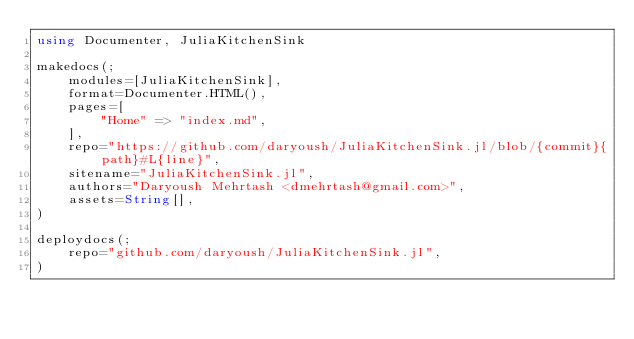<code> <loc_0><loc_0><loc_500><loc_500><_Julia_>using Documenter, JuliaKitchenSink

makedocs(;
    modules=[JuliaKitchenSink],
    format=Documenter.HTML(),
    pages=[
        "Home" => "index.md",
    ],
    repo="https://github.com/daryoush/JuliaKitchenSink.jl/blob/{commit}{path}#L{line}",
    sitename="JuliaKitchenSink.jl",
    authors="Daryoush Mehrtash <dmehrtash@gmail.com>",
    assets=String[],
)

deploydocs(;
    repo="github.com/daryoush/JuliaKitchenSink.jl",
)
</code> 